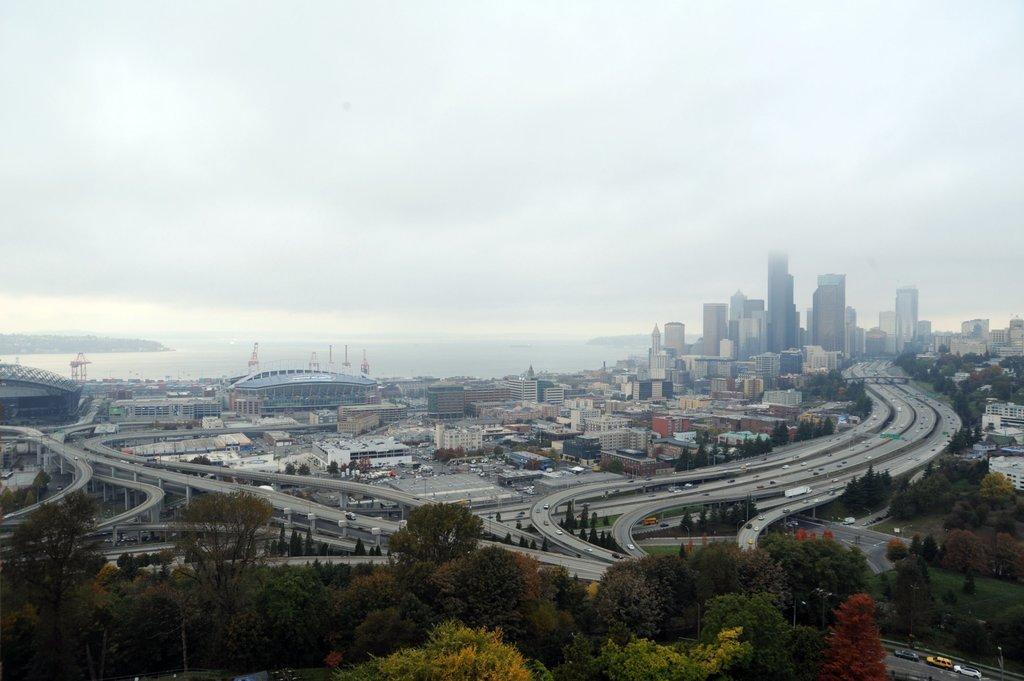How would you summarize this image in a sentence or two? At the center of the image there are buildings, roads and some vehicles are on the road. At the bottom of the image there are trees. In the background there is a river and sky. 